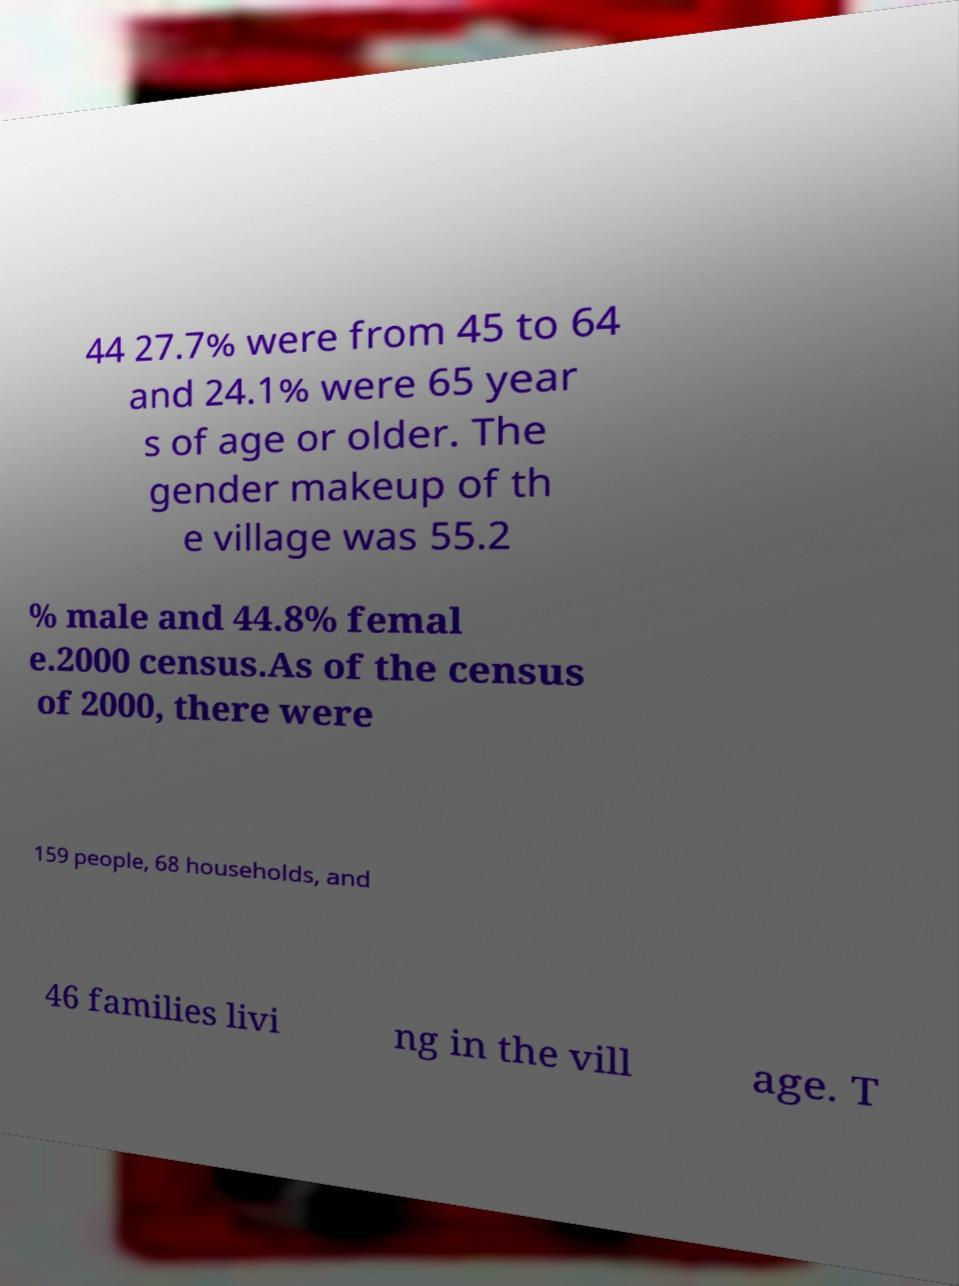Could you extract and type out the text from this image? 44 27.7% were from 45 to 64 and 24.1% were 65 year s of age or older. The gender makeup of th e village was 55.2 % male and 44.8% femal e.2000 census.As of the census of 2000, there were 159 people, 68 households, and 46 families livi ng in the vill age. T 